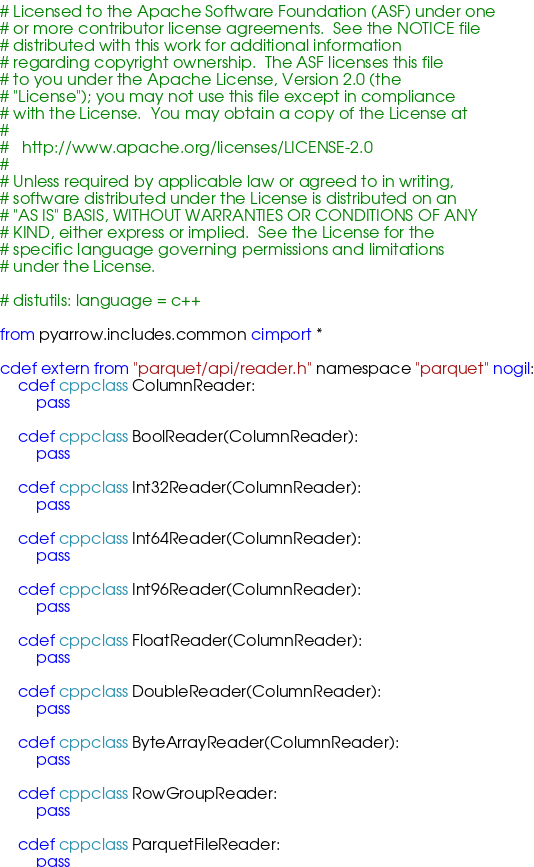<code> <loc_0><loc_0><loc_500><loc_500><_Cython_># Licensed to the Apache Software Foundation (ASF) under one
# or more contributor license agreements.  See the NOTICE file
# distributed with this work for additional information
# regarding copyright ownership.  The ASF licenses this file
# to you under the Apache License, Version 2.0 (the
# "License"); you may not use this file except in compliance
# with the License.  You may obtain a copy of the License at
#
#   http://www.apache.org/licenses/LICENSE-2.0
#
# Unless required by applicable law or agreed to in writing,
# software distributed under the License is distributed on an
# "AS IS" BASIS, WITHOUT WARRANTIES OR CONDITIONS OF ANY
# KIND, either express or implied.  See the License for the
# specific language governing permissions and limitations
# under the License.

# distutils: language = c++

from pyarrow.includes.common cimport *

cdef extern from "parquet/api/reader.h" namespace "parquet" nogil:
    cdef cppclass ColumnReader:
        pass

    cdef cppclass BoolReader(ColumnReader):
        pass

    cdef cppclass Int32Reader(ColumnReader):
        pass

    cdef cppclass Int64Reader(ColumnReader):
        pass

    cdef cppclass Int96Reader(ColumnReader):
        pass

    cdef cppclass FloatReader(ColumnReader):
        pass

    cdef cppclass DoubleReader(ColumnReader):
        pass

    cdef cppclass ByteArrayReader(ColumnReader):
        pass

    cdef cppclass RowGroupReader:
        pass

    cdef cppclass ParquetFileReader:
        pass
</code> 